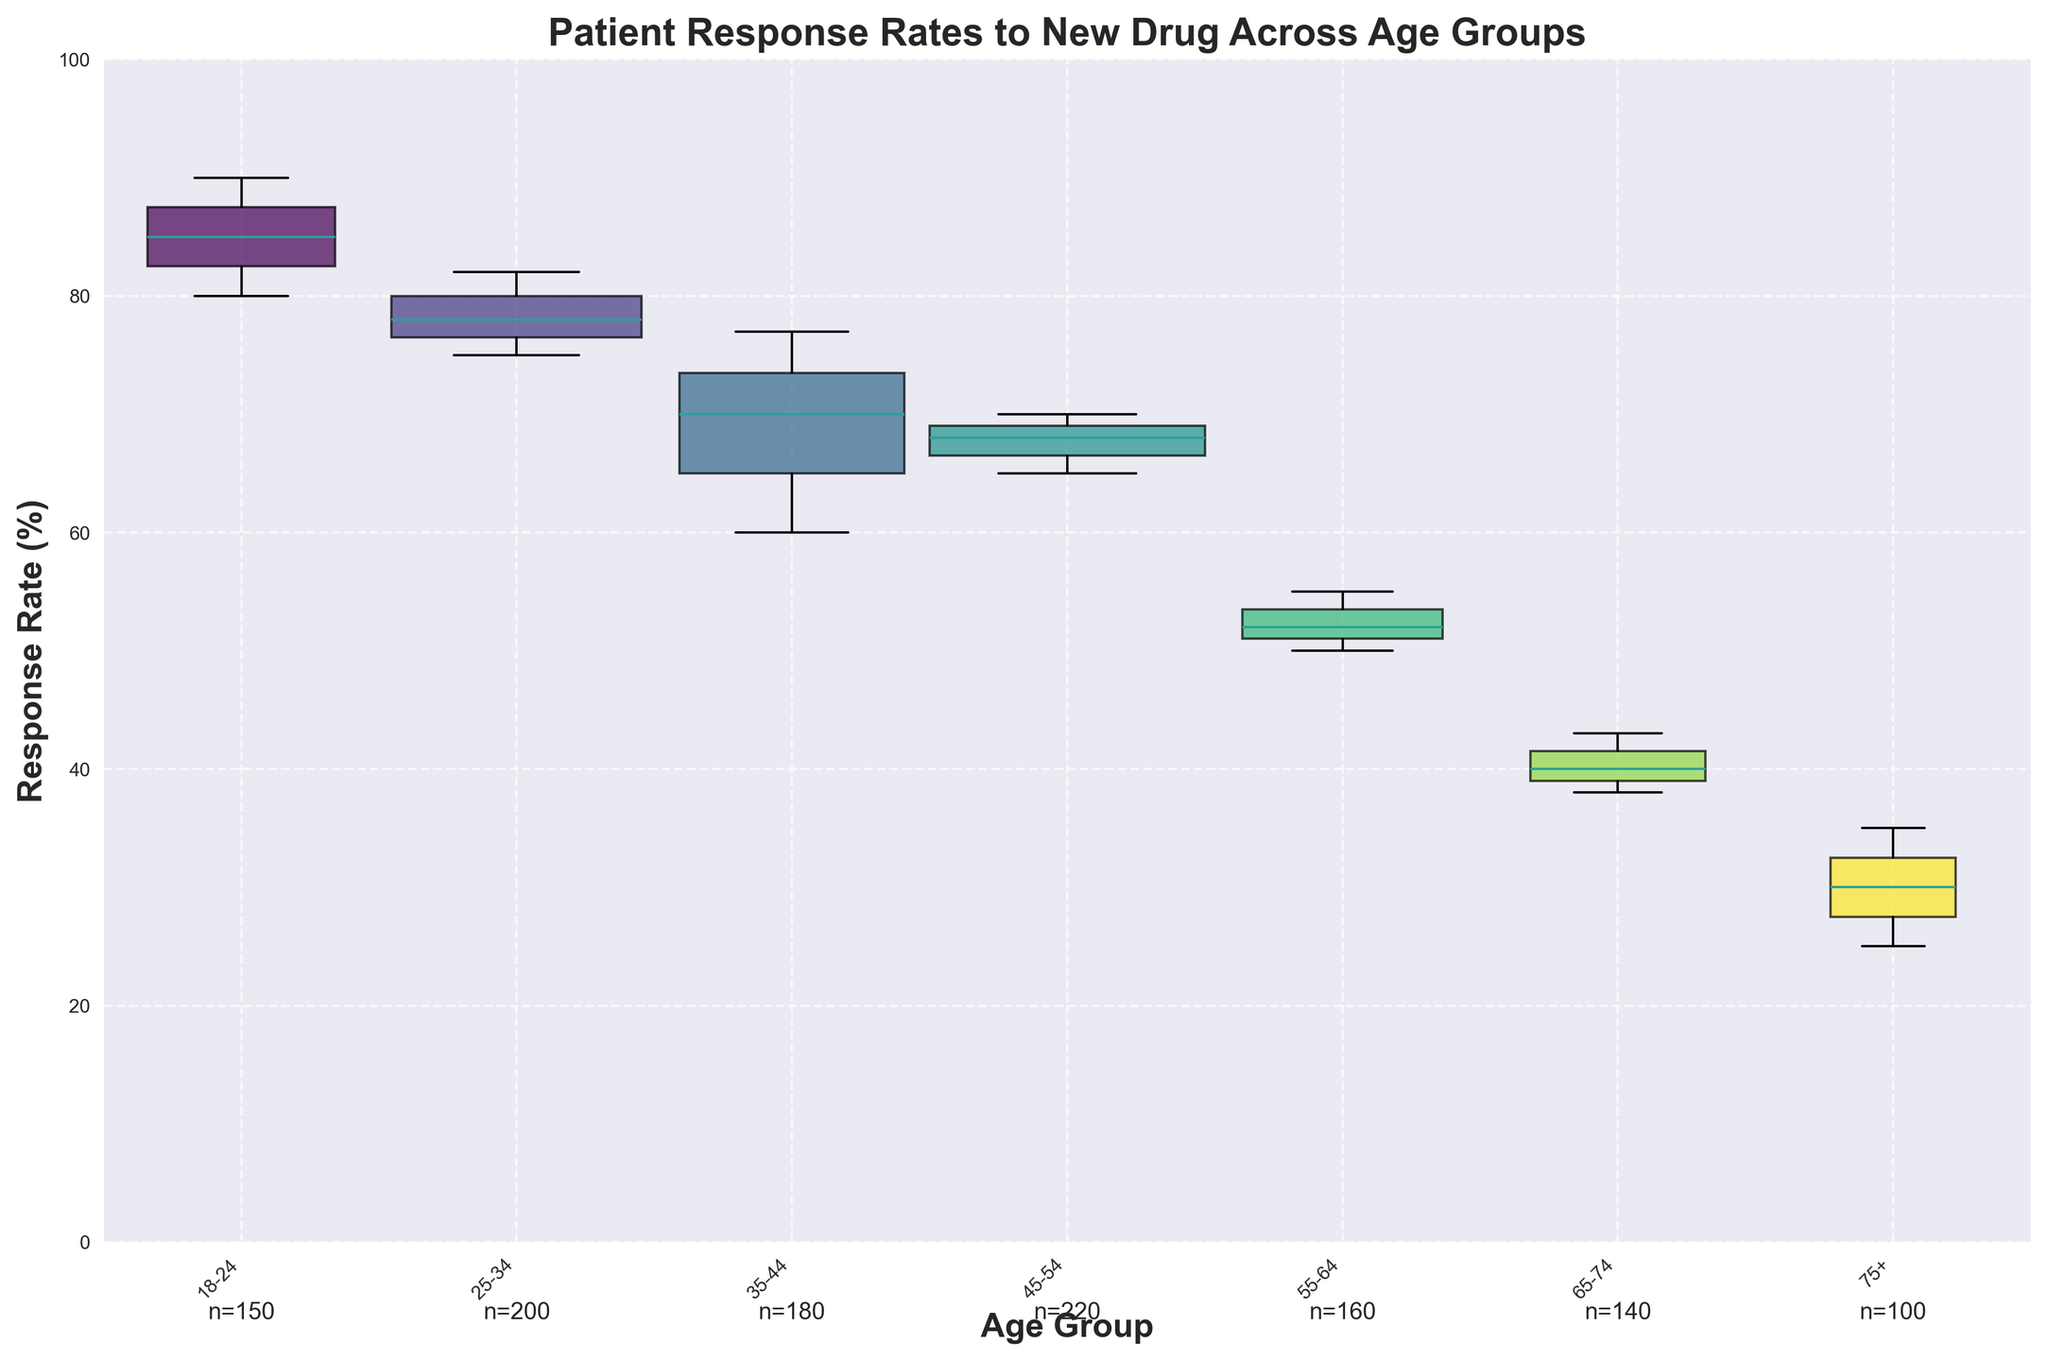What is the title of the figure? Look at the top of the figure where the title is typically located.
Answer: Patient Response Rates to New Drug Across Age Groups What are the age groups displayed in the figure? The x-axis shows the various age groups as labels; you can read them directly.
Answer: 18-24, 25-34, 35-44, 45-54, 55-64, 65-74, 75+ Which age group has the highest median response rate? Identify the median line within each boxplot and compare their positions. The group with the highest median line has the highest median response rate.
Answer: 18-24 Which age group has the widest box, indicating the most variability in response rates? Look for the box with the largest vertical height which represents the highest interquartile range.
Answer: 35-44 What is the median response rate for the 55-64 age group? Find the boxplot for the 55-64 age group and locate the middle line of the box, which represents the median.
Answer: 52% Between which two age groups is the difference in median response rate the greatest? Compare the heights of the medians for all age groups and identify the two groups with the maximum difference between their medians.
Answer: 18-24 and 75+ Which age group has the smallest sample size? The sample sizes are displayed below each age group; find the one with the smallest number.
Answer: 75+ Comparing 25-34 and 45-54 age groups, which one has a higher lower quartile (25th percentile) response rate? Compare the bottom edges of the boxes for both age groups; the one higher up indicates a higher 25th percentile.
Answer: 25-34 In which age group is the interquartile range (IQR) the smallest? The IQR is represented by the height of the box; find the box with the smallest vertical height.
Answer: 75+ Which age group has the most data points beyond the whiskers (potential outliers)? Look for the age group with the most data points marked as dots outside the boxes (whiskers).
Answer: 18-24 